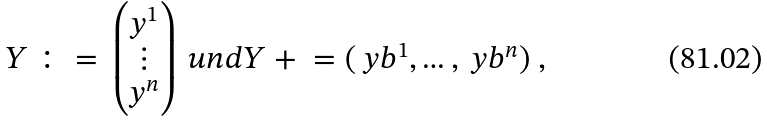Convert formula to latex. <formula><loc_0><loc_0><loc_500><loc_500>Y \ \colon = \ \begin{pmatrix} y ^ { 1 } \\ \vdots \\ y ^ { n } \end{pmatrix} \ u n d Y ^ { \ } + \ = ( \ y b ^ { 1 } , \dots , \ y b ^ { n } ) \ ,</formula> 